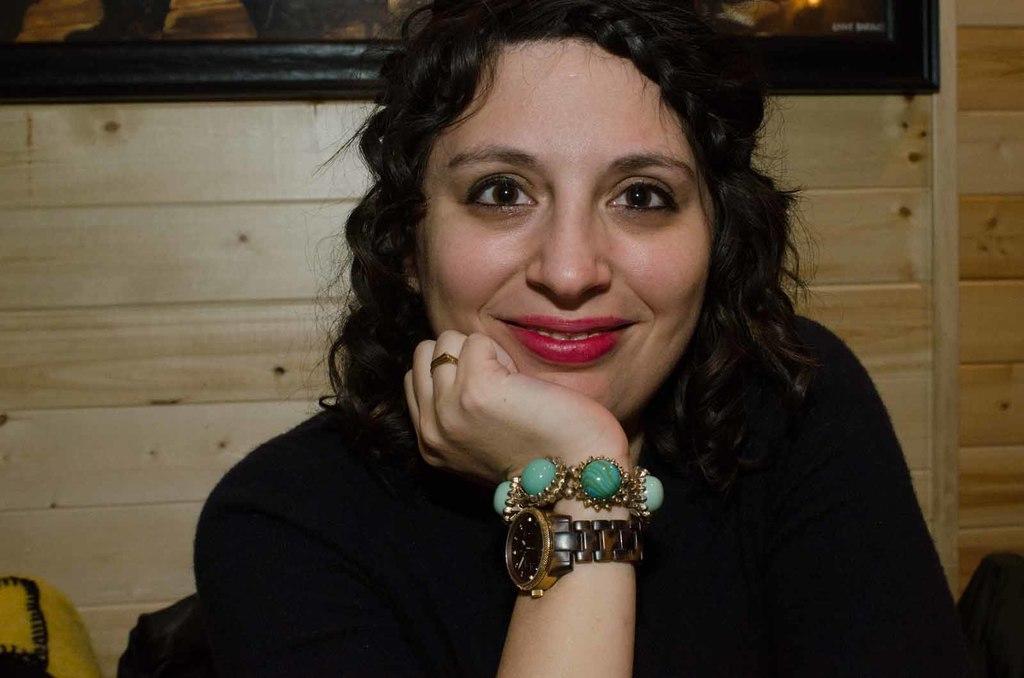Could you give a brief overview of what you see in this image? In this image there is a girl looking to the camera, behind her there is a frame hanging on the wooden wall. 